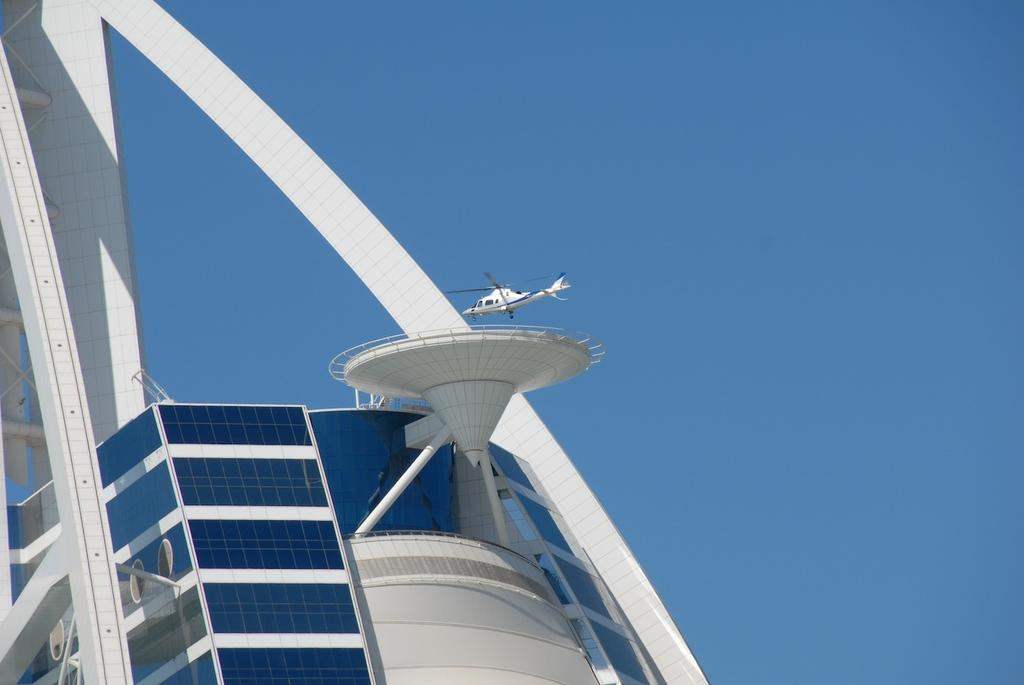What type of structure is present in the image? There is a building in the image. What feature is present on top of the building? There is a helipad on top of the building. What is located on the helipad? There is a helicopter on the helipad. What can be seen in the background of the image? The sky is visible in the background of the image. What type of creature can be seen holding a piece of chalk in the image? There is no creature holding a piece of chalk present in the image. Can you tell me how many owls are sitting on the helicopter in the image? There are no owls present in the image; it features a building with a helipad and a helicopter. 